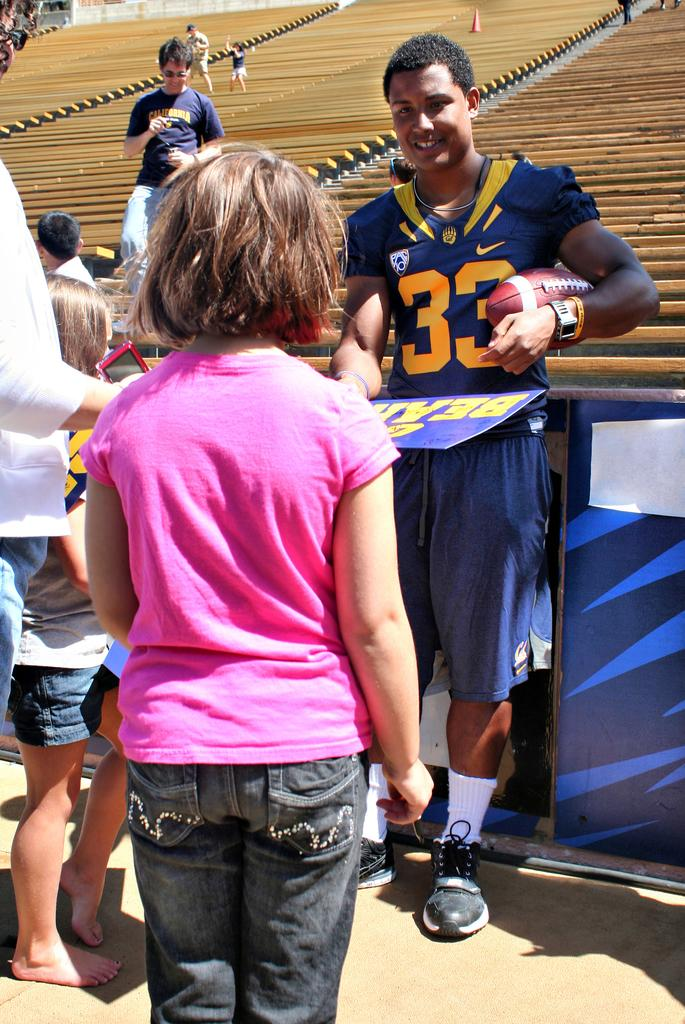<image>
Share a concise interpretation of the image provided. A Cal football player wearing number 33 signs autographs for fans. 